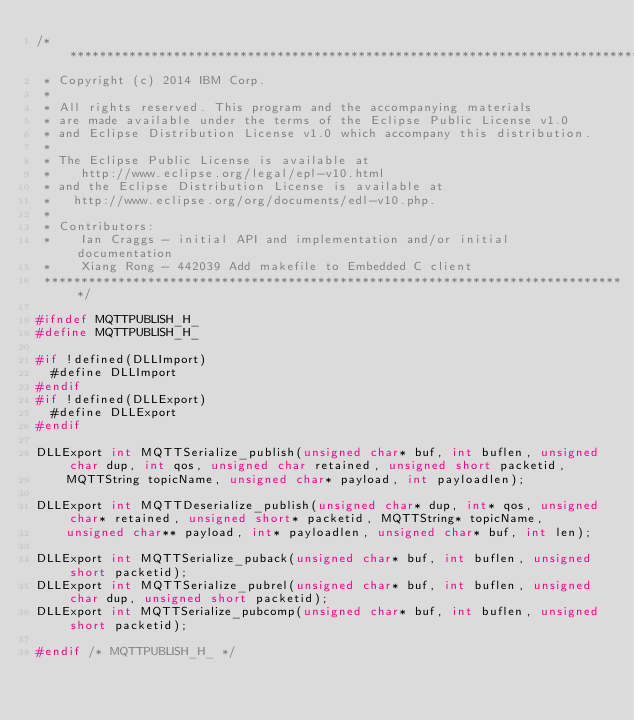<code> <loc_0><loc_0><loc_500><loc_500><_C_>/*******************************************************************************
 * Copyright (c) 2014 IBM Corp.
 *
 * All rights reserved. This program and the accompanying materials
 * are made available under the terms of the Eclipse Public License v1.0
 * and Eclipse Distribution License v1.0 which accompany this distribution.
 *
 * The Eclipse Public License is available at
 *    http://www.eclipse.org/legal/epl-v10.html
 * and the Eclipse Distribution License is available at
 *   http://www.eclipse.org/org/documents/edl-v10.php.
 *
 * Contributors:
 *    Ian Craggs - initial API and implementation and/or initial documentation
 *    Xiang Rong - 442039 Add makefile to Embedded C client
 *******************************************************************************/

#ifndef MQTTPUBLISH_H_
#define MQTTPUBLISH_H_

#if !defined(DLLImport)
  #define DLLImport
#endif
#if !defined(DLLExport)
  #define DLLExport
#endif

DLLExport int MQTTSerialize_publish(unsigned char* buf, int buflen, unsigned char dup, int qos, unsigned char retained, unsigned short packetid,
		MQTTString topicName, unsigned char* payload, int payloadlen);

DLLExport int MQTTDeserialize_publish(unsigned char* dup, int* qos, unsigned char* retained, unsigned short* packetid, MQTTString* topicName,
		unsigned char** payload, int* payloadlen, unsigned char* buf, int len);

DLLExport int MQTTSerialize_puback(unsigned char* buf, int buflen, unsigned short packetid);
DLLExport int MQTTSerialize_pubrel(unsigned char* buf, int buflen, unsigned char dup, unsigned short packetid);
DLLExport int MQTTSerialize_pubcomp(unsigned char* buf, int buflen, unsigned short packetid);

#endif /* MQTTPUBLISH_H_ */
</code> 